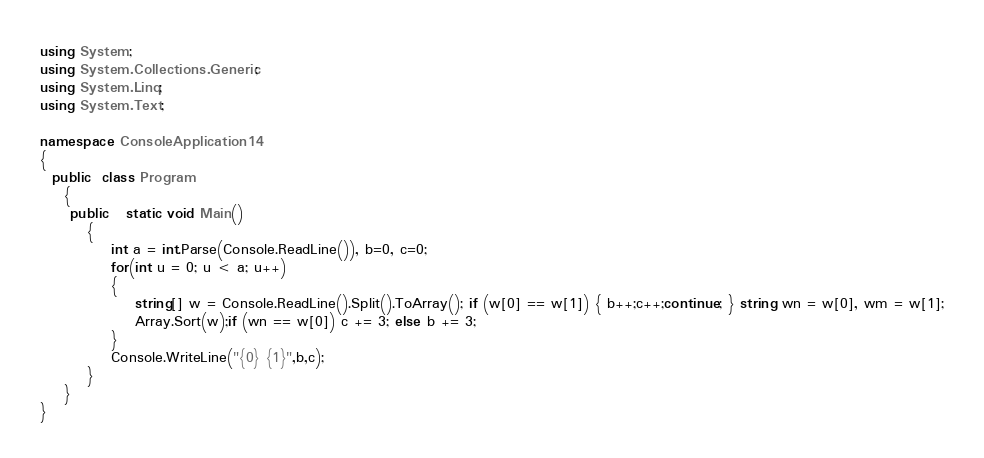<code> <loc_0><loc_0><loc_500><loc_500><_C#_>using System;
using System.Collections.Generic;
using System.Linq;
using System.Text;

namespace ConsoleApplication14
{
  public  class Program
    {
     public   static void Main()
        {
            int a = int.Parse(Console.ReadLine()), b=0, c=0;
            for(int u = 0; u < a; u++)
            {
                string[] w = Console.ReadLine().Split().ToArray(); if (w[0] == w[1]) { b++;c++;continue; } string wn = w[0], wm = w[1];
                Array.Sort(w);if (wn == w[0]) c += 3; else b += 3;
            }
            Console.WriteLine("{0} {1}",b,c);
        }
    }
}</code> 